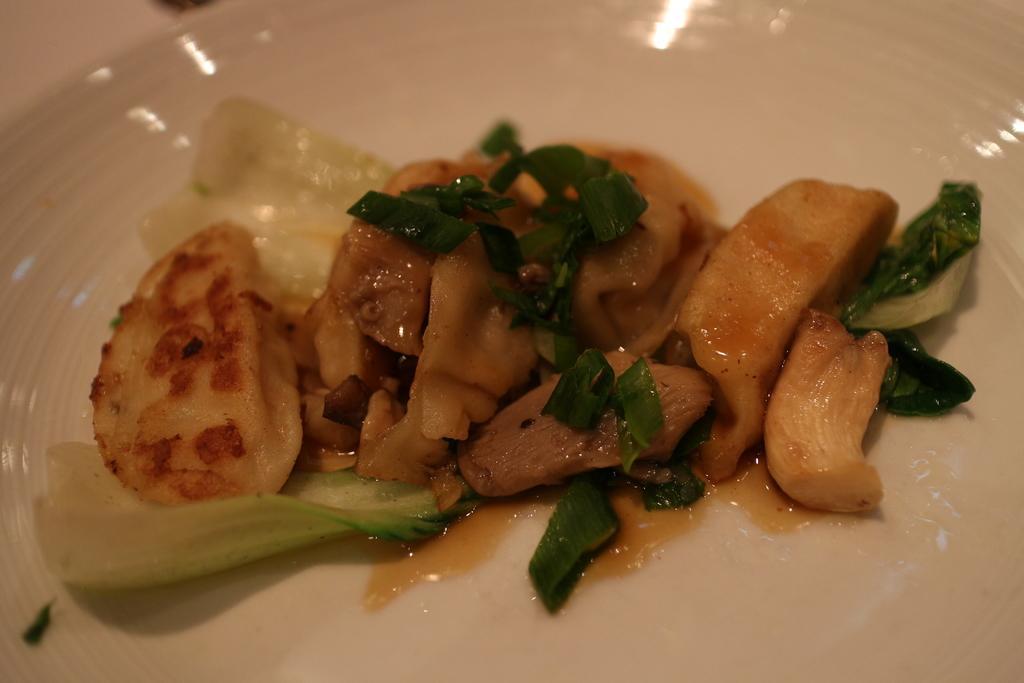Please provide a concise description of this image. In this image, we can see food on the plate. 